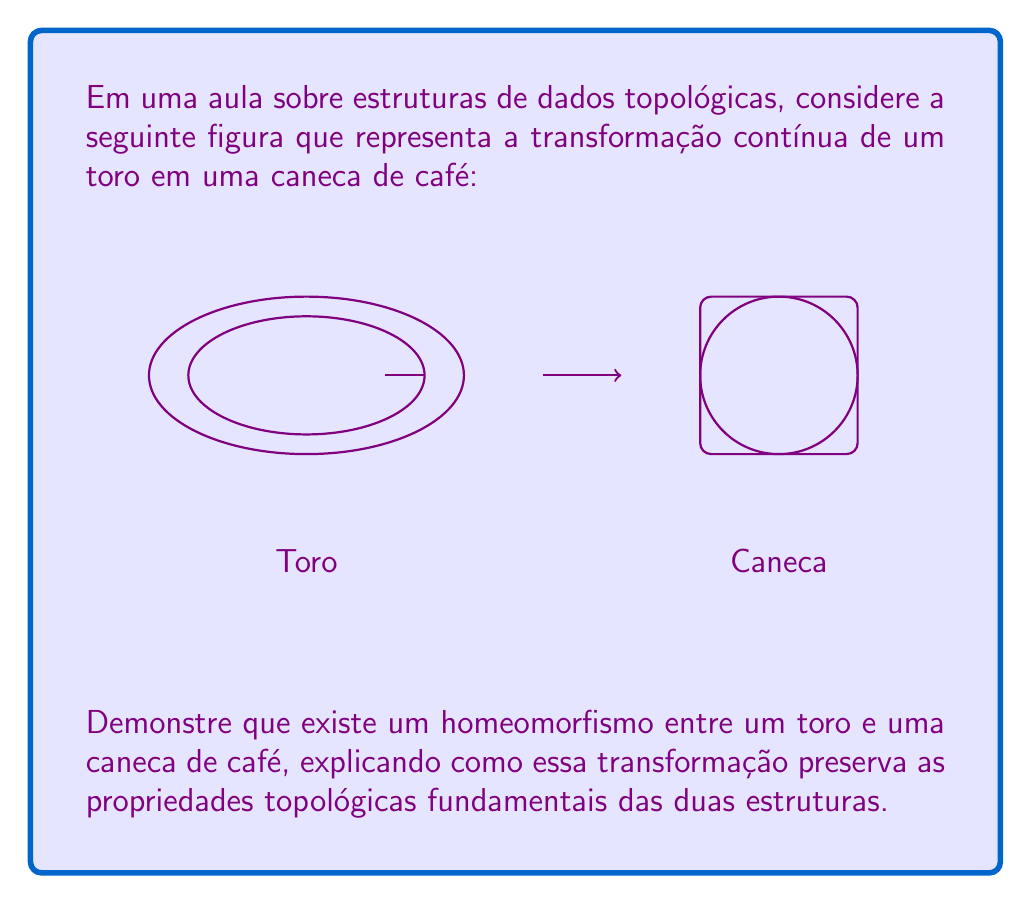What is the answer to this math problem? Para demonstrar o homeomorfismo entre um toro e uma caneca de café, seguiremos os seguintes passos:

1) Definição de homeomorfismo: Duas estruturas topológicas são homeomorfas se existe uma função contínua e bijetora entre elas, cuja inversa também é contínua.

2) Transformação contínua:
   a) Comece com um toro sólido.
   b) Faça uma "depressão" em um lado do toro, criando gradualmente uma cavidade.
   c) Expanda essa cavidade até que ela se torne o interior da caneca.
   d) Alongue uma parte do toro para formar a alça da caneca.

3) Propriedades preservadas:
   a) Conectividade: Tanto o toro quanto a caneca são objetos de uma só peça.
   b) Orientabilidade: Ambos são orientáveis.
   c) Genus: Ambos têm genus 1, ou seja, possuem um "buraco" (a alça do toro torna-se a alça da caneca).

4) Bijeção: Cada ponto do toro corresponde a um único ponto da caneca e vice-versa.

5) Continuidade: A transformação e sua inversa são contínuas, não há "rasgos" ou "colagens".

6) Invariância topológica: O número de Euler-Poincaré $\chi = V - E + F$ permanece constante (onde V, E e F são vértices, arestas e faces em uma triangulação da superfície).

Matematicamente, podemos expressar o homeomorfismo como uma função $f: T \to C$, onde $T$ é o toro e $C$ é a caneca, tal que $f$ e $f^{-1}$ são contínuas e bijetoras.

$$f: T \to C, \quad f^{-1}: C \to T$$

A existência desta função $f$ e sua inversa demonstra o homeomorfismo entre as duas estruturas.
Answer: Toro e caneca são homeomorfos: existe uma transformação contínua e bijetora entre eles que preserva o genus 1 e outras propriedades topológicas. 